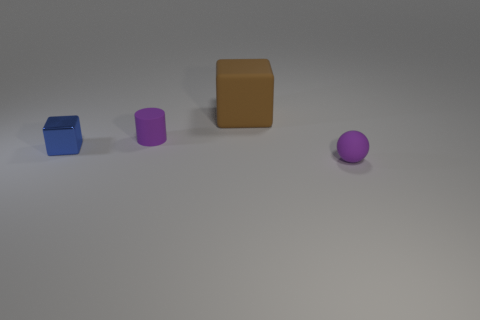What number of objects are metallic things or purple matte spheres?
Offer a terse response. 2. What number of cylinders have the same color as the small metallic cube?
Give a very brief answer. 0. There is a blue thing that is the same size as the purple matte cylinder; what is its shape?
Offer a very short reply. Cube. Are there any large brown rubber objects of the same shape as the tiny blue shiny thing?
Provide a succinct answer. Yes. What number of blocks have the same material as the small cylinder?
Your answer should be compact. 1. Does the object to the right of the big brown rubber thing have the same material as the blue object?
Offer a very short reply. No. Is the number of tiny things in front of the small metal cube greater than the number of balls behind the purple sphere?
Keep it short and to the point. Yes. What is the material of the blue thing that is the same size as the cylinder?
Your answer should be very brief. Metal. How many other objects are there of the same material as the purple cylinder?
Keep it short and to the point. 2. There is a rubber object that is behind the small rubber cylinder; is it the same shape as the tiny object that is on the left side of the small purple matte cylinder?
Your answer should be compact. Yes. 